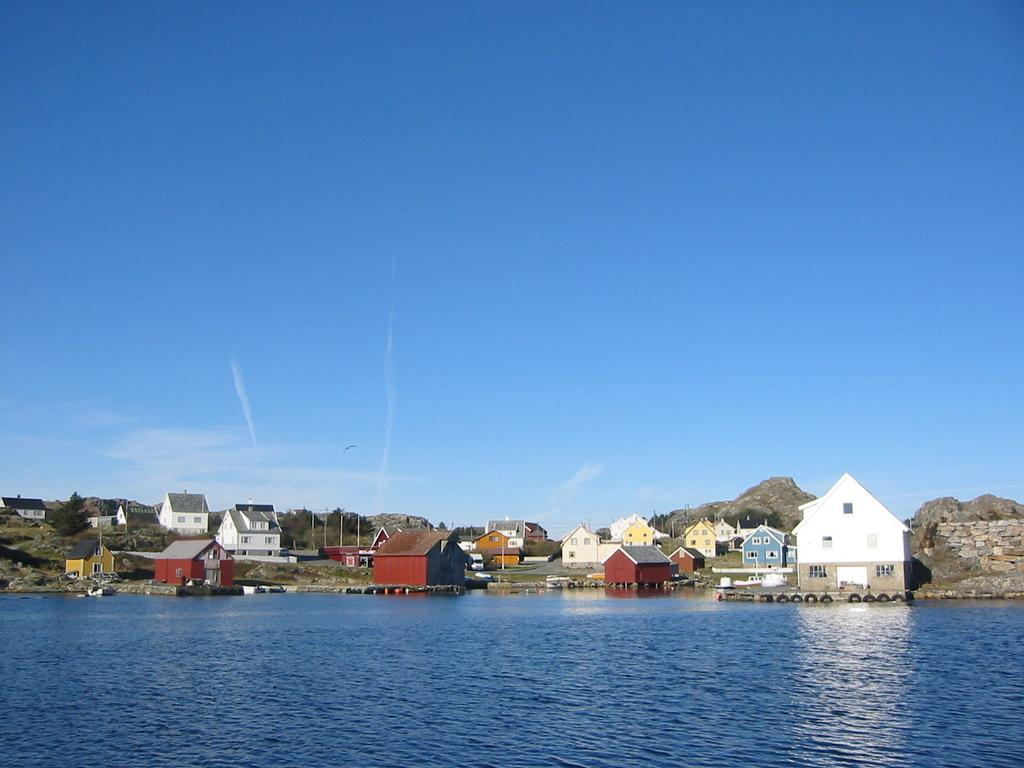What type of natural feature is at the bottom of the image? There is a river at the bottom of the image. What structures can be seen in the background of the image? There are houses in the background of the image. What type of geographical feature is visible in the background of the image? There are mountains in the background of the image. What is visible at the top of the image? The sky is visible at the top of the image. Where is the office located in the image? There is no office present in the image. What shape is the river in the image? The shape of the river cannot be determined from the image alone, as it is a two-dimensional representation. 